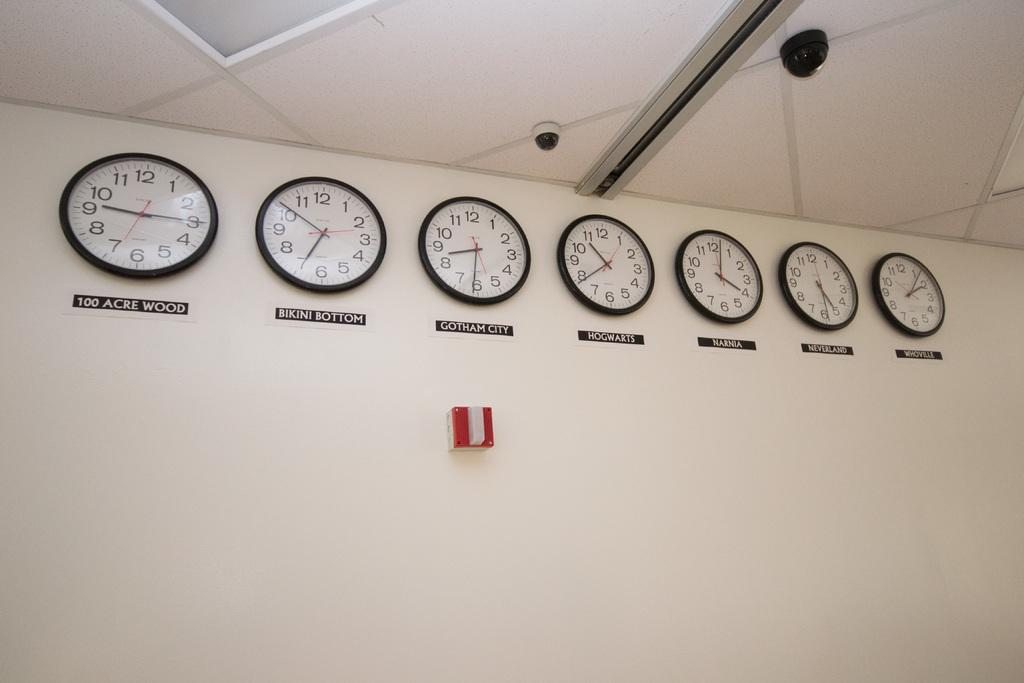<image>
Relay a brief, clear account of the picture shown. Different clocks on time zones from various cities like Gotham City and Hogwarts. 